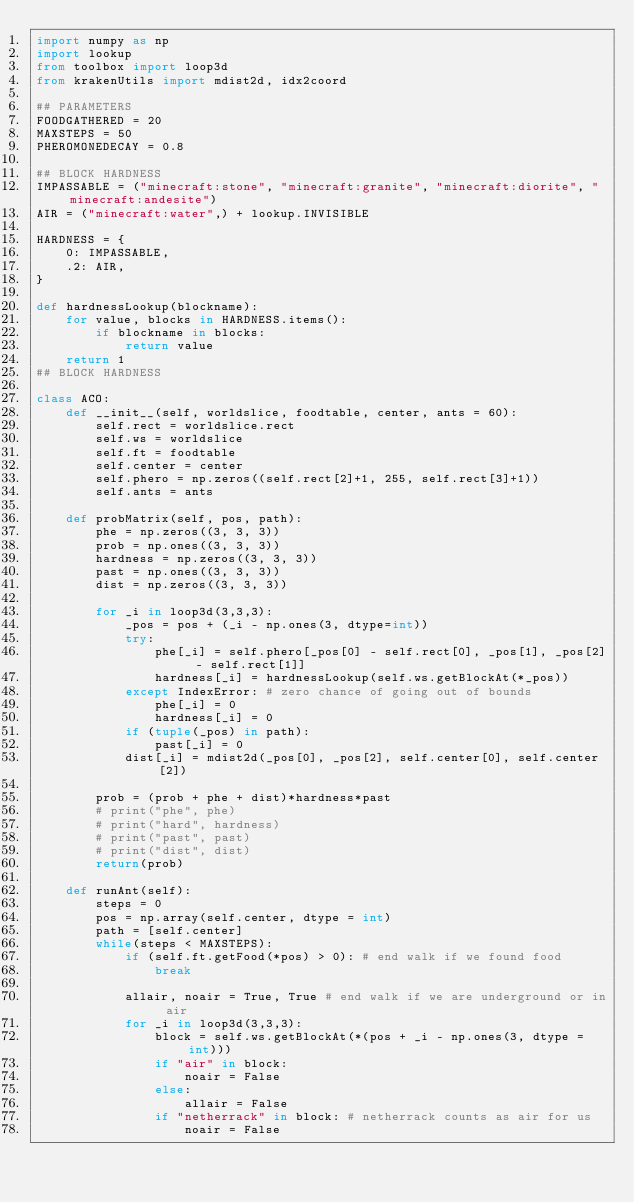Convert code to text. <code><loc_0><loc_0><loc_500><loc_500><_Python_>import numpy as np
import lookup
from toolbox import loop3d
from krakenUtils import mdist2d, idx2coord

## PARAMETERS
FOODGATHERED = 20
MAXSTEPS = 50
PHEROMONEDECAY = 0.8

## BLOCK HARDNESS
IMPASSABLE = ("minecraft:stone", "minecraft:granite", "minecraft:diorite", "minecraft:andesite")
AIR = ("minecraft:water",) + lookup.INVISIBLE

HARDNESS = {
    0: IMPASSABLE,
    .2: AIR,
}

def hardnessLookup(blockname):
    for value, blocks in HARDNESS.items():
        if blockname in blocks:
            return value
    return 1
## BLOCK HARDNESS

class ACO:
    def __init__(self, worldslice, foodtable, center, ants = 60):
        self.rect = worldslice.rect
        self.ws = worldslice
        self.ft = foodtable
        self.center = center
        self.phero = np.zeros((self.rect[2]+1, 255, self.rect[3]+1))
        self.ants = ants

    def probMatrix(self, pos, path):
        phe = np.zeros((3, 3, 3))
        prob = np.ones((3, 3, 3))
        hardness = np.zeros((3, 3, 3))
        past = np.ones((3, 3, 3))
        dist = np.zeros((3, 3, 3))

        for _i in loop3d(3,3,3):
            _pos = pos + (_i - np.ones(3, dtype=int))
            try:
                phe[_i] = self.phero[_pos[0] - self.rect[0], _pos[1], _pos[2] - self.rect[1]]
                hardness[_i] = hardnessLookup(self.ws.getBlockAt(*_pos))
            except IndexError: # zero chance of going out of bounds
                phe[_i] = 0
                hardness[_i] = 0
            if (tuple(_pos) in path):
                past[_i] = 0
            dist[_i] = mdist2d(_pos[0], _pos[2], self.center[0], self.center[2])

        prob = (prob + phe + dist)*hardness*past
        # print("phe", phe)
        # print("hard", hardness)
        # print("past", past)
        # print("dist", dist)
        return(prob)

    def runAnt(self):
        steps = 0
        pos = np.array(self.center, dtype = int)
        path = [self.center]
        while(steps < MAXSTEPS):
            if (self.ft.getFood(*pos) > 0): # end walk if we found food
                break

            allair, noair = True, True # end walk if we are underground or in air
            for _i in loop3d(3,3,3):
                block = self.ws.getBlockAt(*(pos + _i - np.ones(3, dtype = int)))
                if "air" in block:
                    noair = False
                else:
                    allair = False
                if "netherrack" in block: # netherrack counts as air for us
                    noair = False</code> 